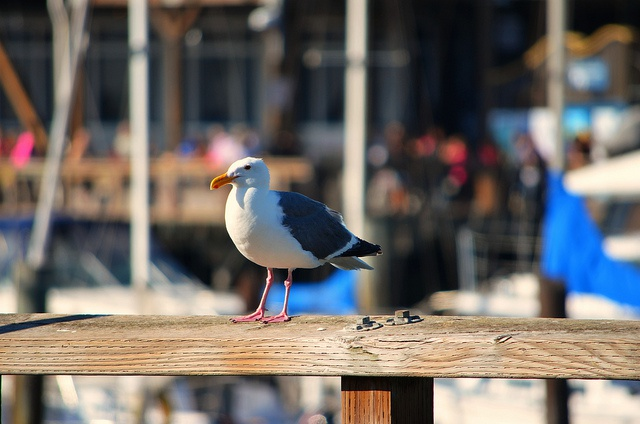Describe the objects in this image and their specific colors. I can see a bird in black, gray, and ivory tones in this image. 